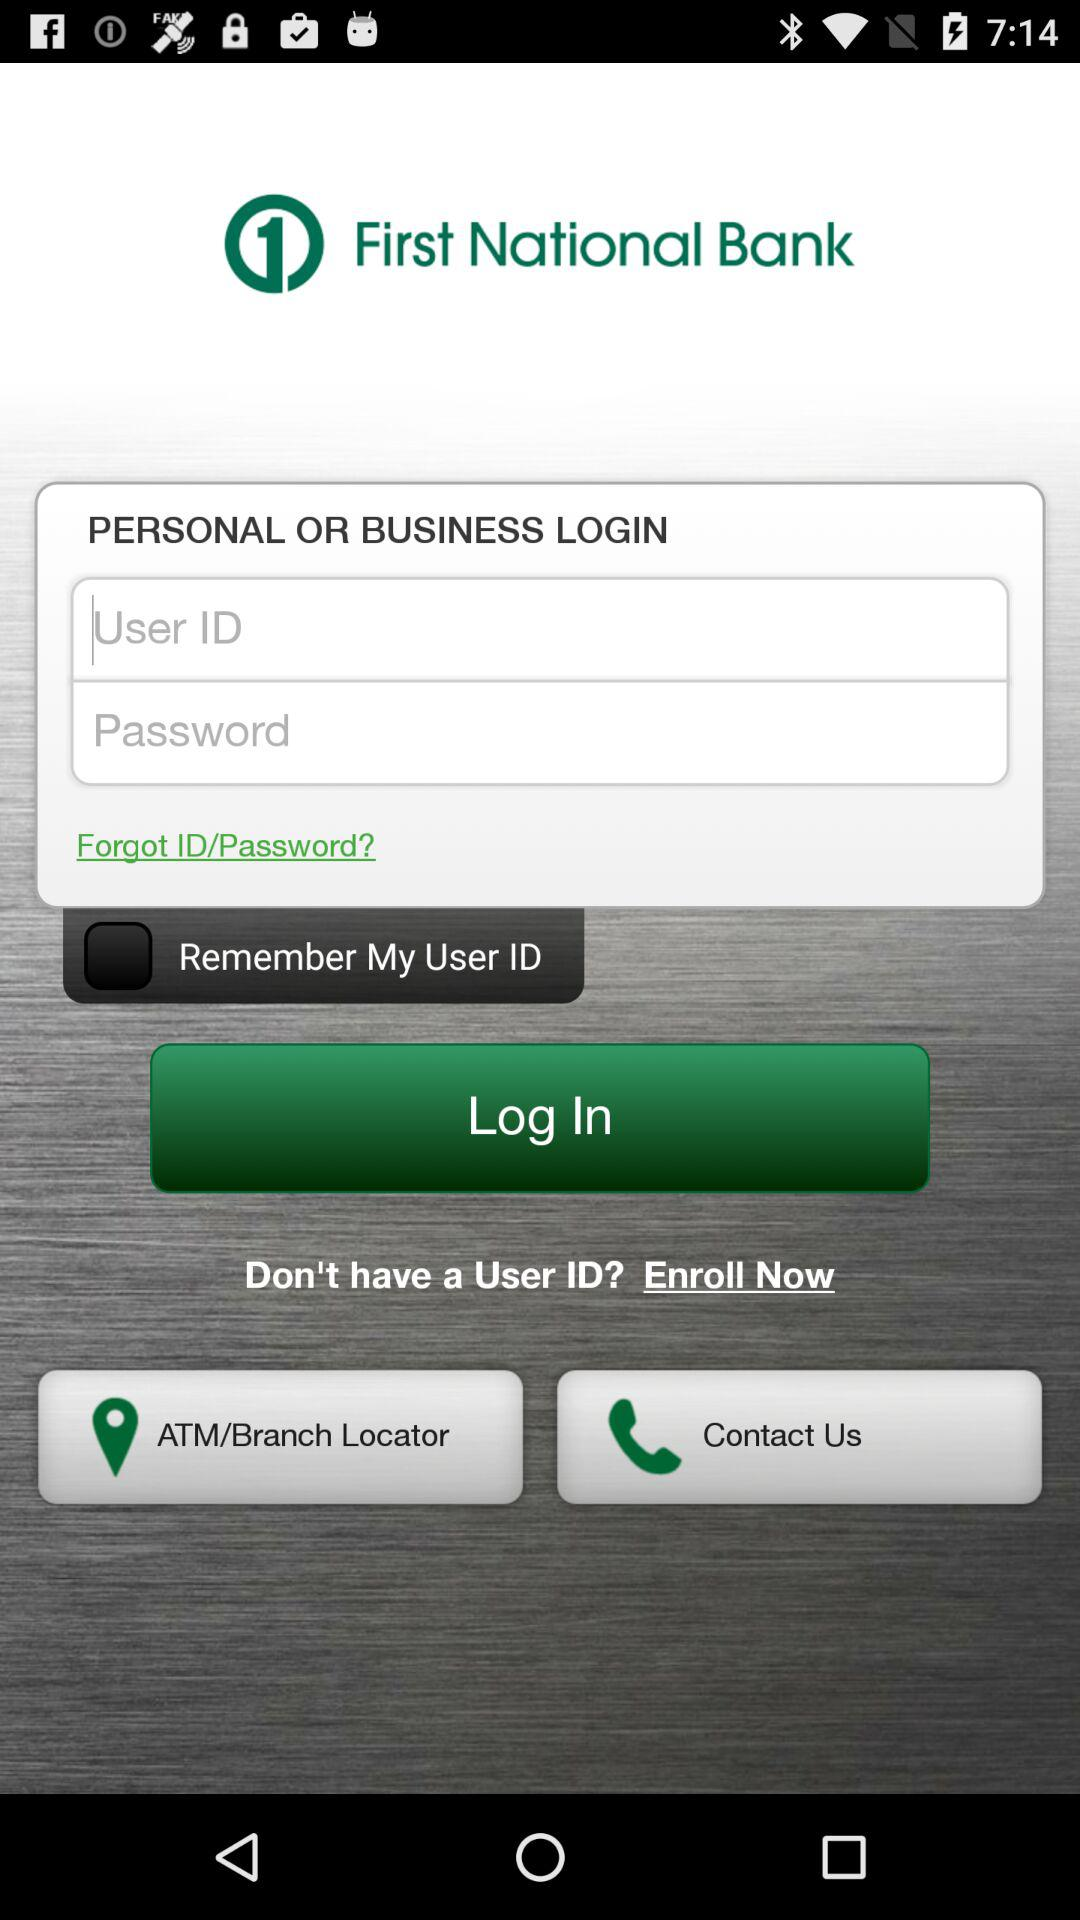What are the requirements to log in? The requirements to log in are a user ID and password. 